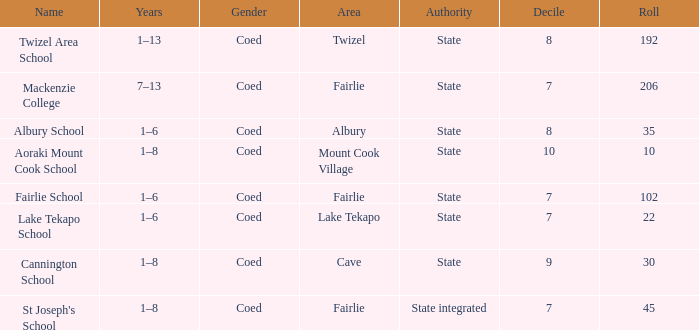What is the total Decile that has a state authority, fairlie area and roll smarter than 206? 1.0. 